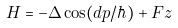Convert formula to latex. <formula><loc_0><loc_0><loc_500><loc_500>H = - \Delta \cos ( d p / \hbar { ) } + F z</formula> 